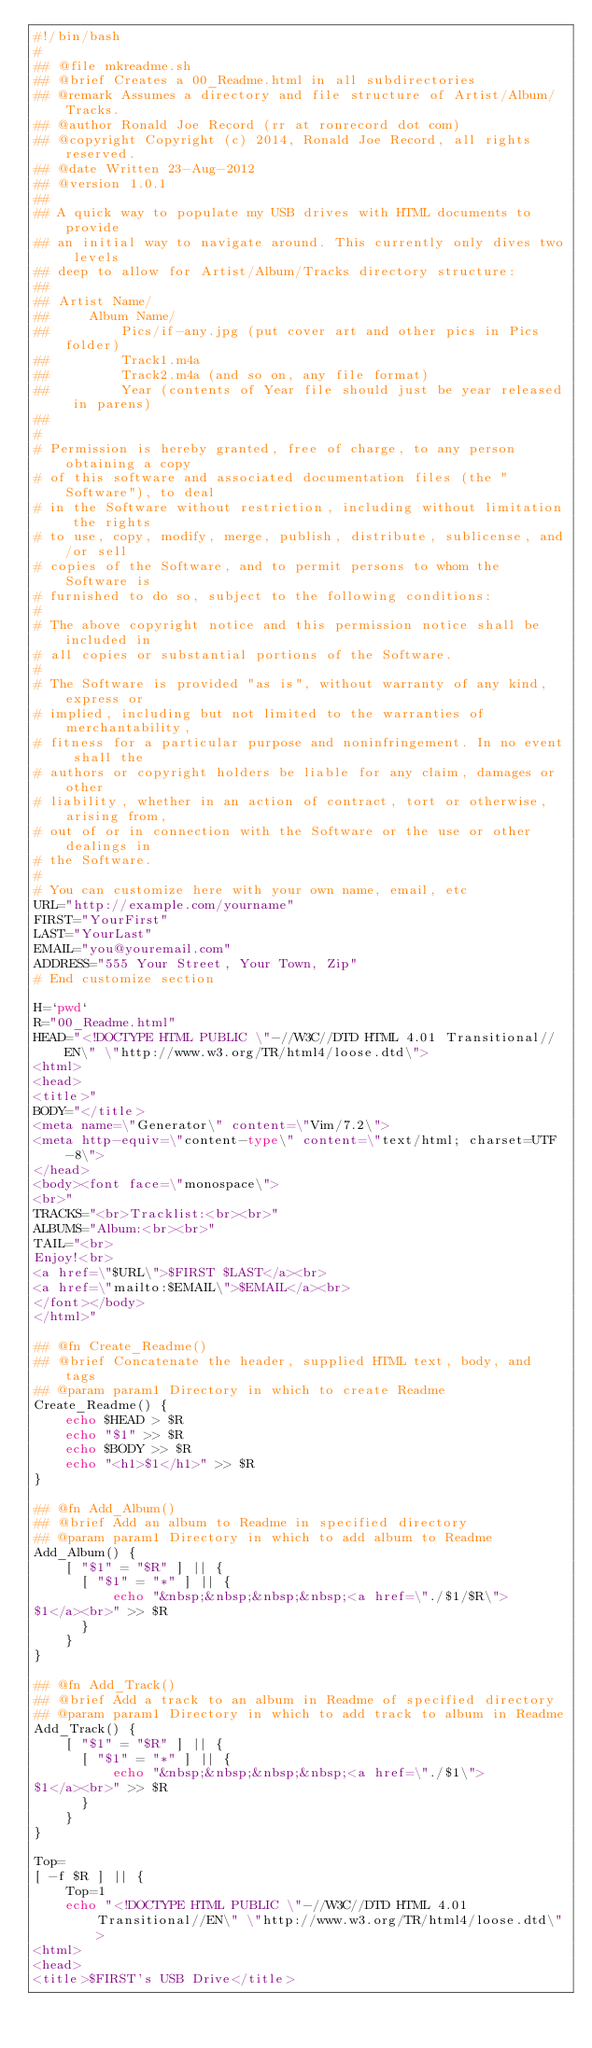<code> <loc_0><loc_0><loc_500><loc_500><_Bash_>#!/bin/bash
#
## @file mkreadme.sh
## @brief Creates a 00_Readme.html in all subdirectories
## @remark Assumes a directory and file structure of Artist/Album/Tracks.
## @author Ronald Joe Record (rr at ronrecord dot com)
## @copyright Copyright (c) 2014, Ronald Joe Record, all rights reserved.
## @date Written 23-Aug-2012
## @version 1.0.1
##
## A quick way to populate my USB drives with HTML documents to provide
## an initial way to navigate around. This currently only dives two levels
## deep to allow for Artist/Album/Tracks directory structure:
##
## Artist Name/
##     Album Name/
##         Pics/if-any.jpg (put cover art and other pics in Pics folder)
##         Track1.m4a
##         Track2.m4a (and so on, any file format)
##         Year (contents of Year file should just be year released in parens)
##
#
# Permission is hereby granted, free of charge, to any person obtaining a copy
# of this software and associated documentation files (the "Software"), to deal
# in the Software without restriction, including without limitation the rights
# to use, copy, modify, merge, publish, distribute, sublicense, and/or sell
# copies of the Software, and to permit persons to whom the Software is
# furnished to do so, subject to the following conditions:
# 
# The above copyright notice and this permission notice shall be included in
# all copies or substantial portions of the Software.
# 
# The Software is provided "as is", without warranty of any kind, express or
# implied, including but not limited to the warranties of merchantability,
# fitness for a particular purpose and noninfringement. In no event shall the
# authors or copyright holders be liable for any claim, damages or other
# liability, whether in an action of contract, tort or otherwise, arising from,
# out of or in connection with the Software or the use or other dealings in
# the Software.
#
# You can customize here with your own name, email, etc
URL="http://example.com/yourname"
FIRST="YourFirst"
LAST="YourLast"
EMAIL="you@youremail.com"
ADDRESS="555 Your Street, Your Town, Zip"
# End customize section

H=`pwd`
R="00_Readme.html"
HEAD="<!DOCTYPE HTML PUBLIC \"-//W3C//DTD HTML 4.01 Transitional//EN\" \"http://www.w3.org/TR/html4/loose.dtd\">
<html>
<head>
<title>"
BODY="</title>
<meta name=\"Generator\" content=\"Vim/7.2\">
<meta http-equiv=\"content-type\" content=\"text/html; charset=UTF-8\">
</head>
<body><font face=\"monospace\">
<br>"
TRACKS="<br>Tracklist:<br><br>"
ALBUMS="Album:<br><br>"
TAIL="<br>
Enjoy!<br>
<a href=\"$URL\">$FIRST $LAST</a><br>
<a href=\"mailto:$EMAIL\">$EMAIL</a><br>
</font></body>
</html>"

## @fn Create_Readme()
## @brief Concatenate the header, supplied HTML text, body, and tags
## @param param1 Directory in which to create Readme
Create_Readme() {
    echo $HEAD > $R
    echo "$1" >> $R
    echo $BODY >> $R
    echo "<h1>$1</h1>" >> $R
}

## @fn Add_Album()
## @brief Add an album to Readme in specified directory
## @param param1 Directory in which to add album to Readme
Add_Album() {
    [ "$1" = "$R" ] || {
      [ "$1" = "*" ] || {
          echo "&nbsp;&nbsp;&nbsp;&nbsp;<a href=\"./$1/$R\">
$1</a><br>" >> $R
      }
    }
}

## @fn Add_Track()
## @brief Add a track to an album in Readme of specified directory
## @param param1 Directory in which to add track to album in Readme
Add_Track() {
    [ "$1" = "$R" ] || {
      [ "$1" = "*" ] || {
          echo "&nbsp;&nbsp;&nbsp;&nbsp;<a href=\"./$1\">
$1</a><br>" >> $R
      }
    }
}

Top=
[ -f $R ] || {
    Top=1
    echo "<!DOCTYPE HTML PUBLIC \"-//W3C//DTD HTML 4.01 Transitional//EN\" \"http://www.w3.org/TR/html4/loose.dtd\">
<html>
<head>
<title>$FIRST's USB Drive</title></code> 